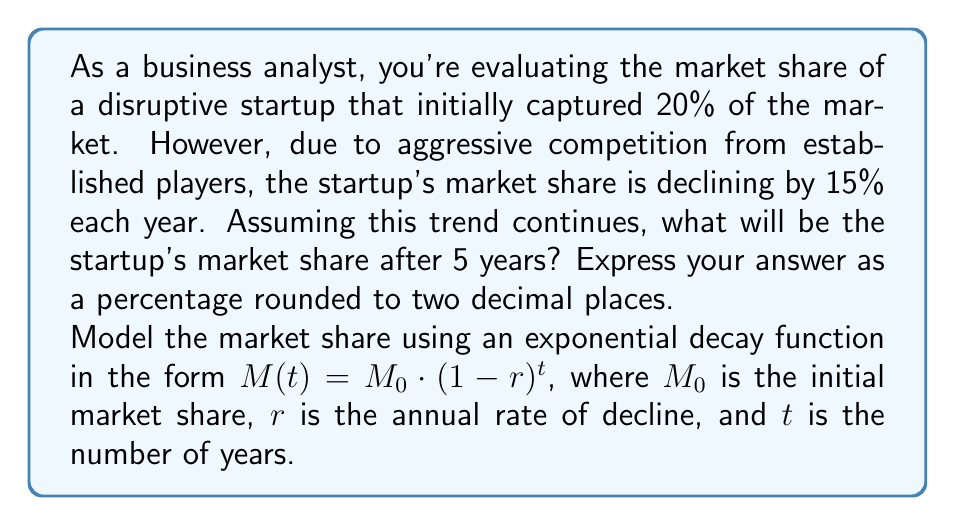Help me with this question. To solve this problem, we'll use the exponential decay function:

$$M(t) = M_0 \cdot (1-r)^t$$

Where:
$M(t)$ = Market share after $t$ years
$M_0$ = Initial market share = 20% = 0.20
$r$ = Annual rate of decline = 15% = 0.15
$t$ = Number of years = 5

Let's substitute these values into the equation:

$$M(5) = 0.20 \cdot (1-0.15)^5$$

Now, let's solve this step-by-step:

1. Calculate $(1-0.15)$:
   $1 - 0.15 = 0.85$

2. Calculate $0.85^5$:
   $0.85^5 \approx 0.4437$

3. Multiply by the initial market share:
   $0.20 \cdot 0.4437 \approx 0.08874$

4. Convert to a percentage:
   $0.08874 \cdot 100\% \approx 8.87\%$

5. Round to two decimal places:
   $8.87\%$
Answer: 8.87% 